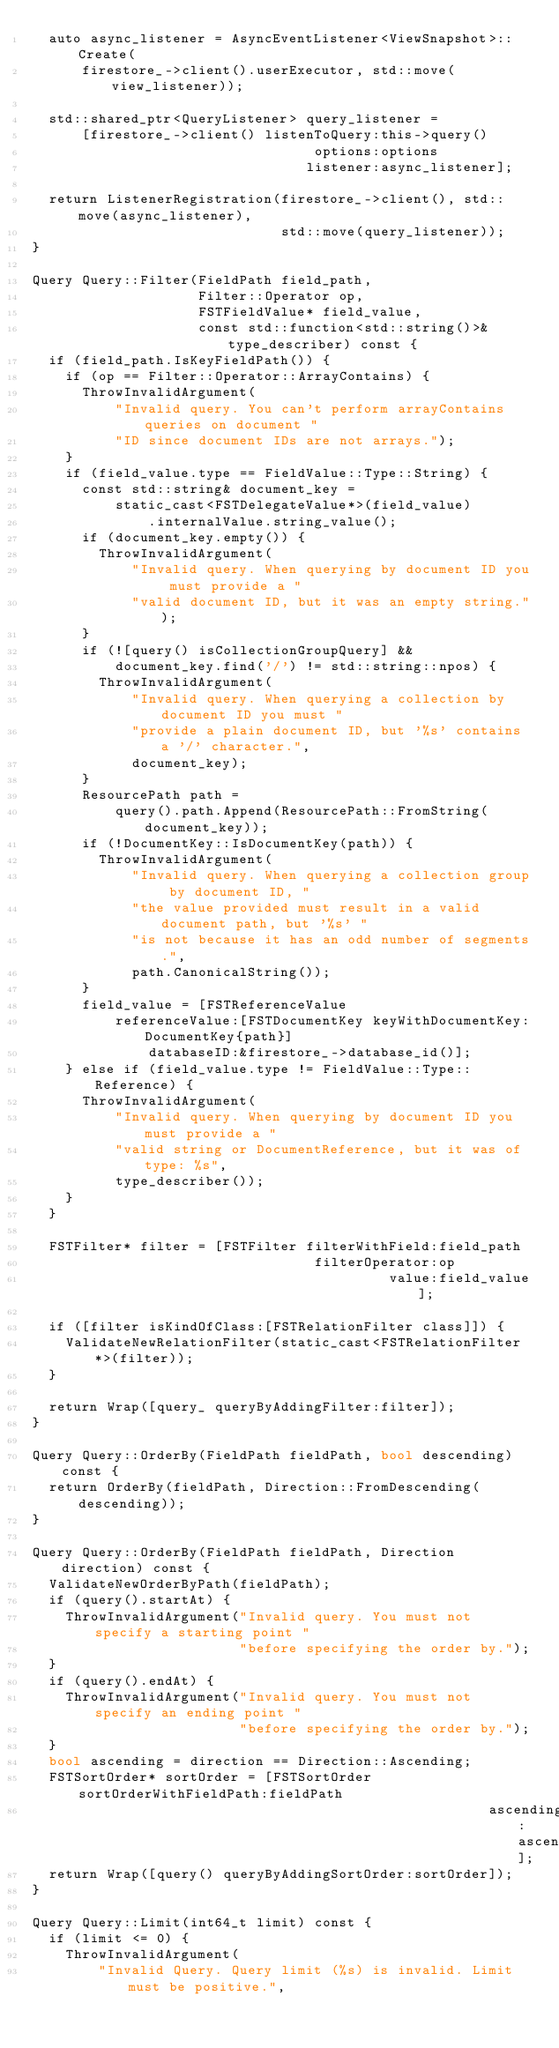Convert code to text. <code><loc_0><loc_0><loc_500><loc_500><_ObjectiveC_>  auto async_listener = AsyncEventListener<ViewSnapshot>::Create(
      firestore_->client().userExecutor, std::move(view_listener));

  std::shared_ptr<QueryListener> query_listener =
      [firestore_->client() listenToQuery:this->query()
                                  options:options
                                 listener:async_listener];

  return ListenerRegistration(firestore_->client(), std::move(async_listener),
                              std::move(query_listener));
}

Query Query::Filter(FieldPath field_path,
                    Filter::Operator op,
                    FSTFieldValue* field_value,
                    const std::function<std::string()>& type_describer) const {
  if (field_path.IsKeyFieldPath()) {
    if (op == Filter::Operator::ArrayContains) {
      ThrowInvalidArgument(
          "Invalid query. You can't perform arrayContains queries on document "
          "ID since document IDs are not arrays.");
    }
    if (field_value.type == FieldValue::Type::String) {
      const std::string& document_key =
          static_cast<FSTDelegateValue*>(field_value)
              .internalValue.string_value();
      if (document_key.empty()) {
        ThrowInvalidArgument(
            "Invalid query. When querying by document ID you must provide a "
            "valid document ID, but it was an empty string.");
      }
      if (![query() isCollectionGroupQuery] &&
          document_key.find('/') != std::string::npos) {
        ThrowInvalidArgument(
            "Invalid query. When querying a collection by document ID you must "
            "provide a plain document ID, but '%s' contains a '/' character.",
            document_key);
      }
      ResourcePath path =
          query().path.Append(ResourcePath::FromString(document_key));
      if (!DocumentKey::IsDocumentKey(path)) {
        ThrowInvalidArgument(
            "Invalid query. When querying a collection group by document ID, "
            "the value provided must result in a valid document path, but '%s' "
            "is not because it has an odd number of segments.",
            path.CanonicalString());
      }
      field_value = [FSTReferenceValue
          referenceValue:[FSTDocumentKey keyWithDocumentKey:DocumentKey{path}]
              databaseID:&firestore_->database_id()];
    } else if (field_value.type != FieldValue::Type::Reference) {
      ThrowInvalidArgument(
          "Invalid query. When querying by document ID you must provide a "
          "valid string or DocumentReference, but it was of type: %s",
          type_describer());
    }
  }

  FSTFilter* filter = [FSTFilter filterWithField:field_path
                                  filterOperator:op
                                           value:field_value];

  if ([filter isKindOfClass:[FSTRelationFilter class]]) {
    ValidateNewRelationFilter(static_cast<FSTRelationFilter*>(filter));
  }

  return Wrap([query_ queryByAddingFilter:filter]);
}

Query Query::OrderBy(FieldPath fieldPath, bool descending) const {
  return OrderBy(fieldPath, Direction::FromDescending(descending));
}

Query Query::OrderBy(FieldPath fieldPath, Direction direction) const {
  ValidateNewOrderByPath(fieldPath);
  if (query().startAt) {
    ThrowInvalidArgument("Invalid query. You must not specify a starting point "
                         "before specifying the order by.");
  }
  if (query().endAt) {
    ThrowInvalidArgument("Invalid query. You must not specify an ending point "
                         "before specifying the order by.");
  }
  bool ascending = direction == Direction::Ascending;
  FSTSortOrder* sortOrder = [FSTSortOrder sortOrderWithFieldPath:fieldPath
                                                       ascending:ascending];
  return Wrap([query() queryByAddingSortOrder:sortOrder]);
}

Query Query::Limit(int64_t limit) const {
  if (limit <= 0) {
    ThrowInvalidArgument(
        "Invalid Query. Query limit (%s) is invalid. Limit must be positive.",</code> 